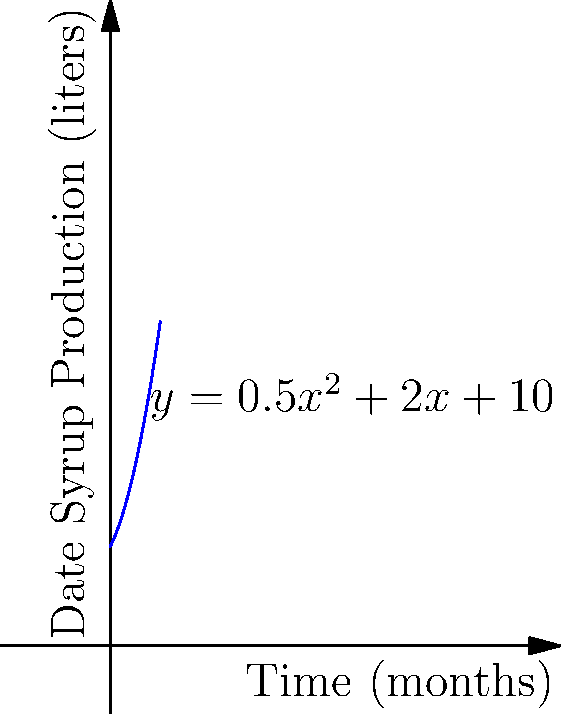The graph represents the date syrup production (in liters) over time (in months) for your company. The production function is given by $y = 0.5x^2 + 2x + 10$, where $x$ is the time in months and $y$ is the production in liters. Calculate the total amount of date syrup produced over the first 5 months. To find the total amount of date syrup produced over the first 5 months, we need to calculate the area under the curve from $x=0$ to $x=5$. This can be done using a definite integral.

1. Set up the integral:
   $$\int_0^5 (0.5x^2 + 2x + 10) dx$$

2. Integrate the function:
   $$\left[ \frac{1}{6}x^3 + x^2 + 10x \right]_0^5$$

3. Evaluate the integral:
   $$\left( \frac{1}{6}(5^3) + 5^2 + 10(5) \right) - \left( \frac{1}{6}(0^3) + 0^2 + 10(0) \right)$$

4. Simplify:
   $$\left( \frac{125}{6} + 25 + 50 \right) - 0$$
   $$= \frac{125}{6} + 75$$
   $$= \frac{125 + 450}{6}$$
   $$= \frac{575}{6}$$
   $$\approx 95.83$$

Therefore, the total amount of date syrup produced over the first 5 months is approximately 95.83 liters.
Answer: 95.83 liters 